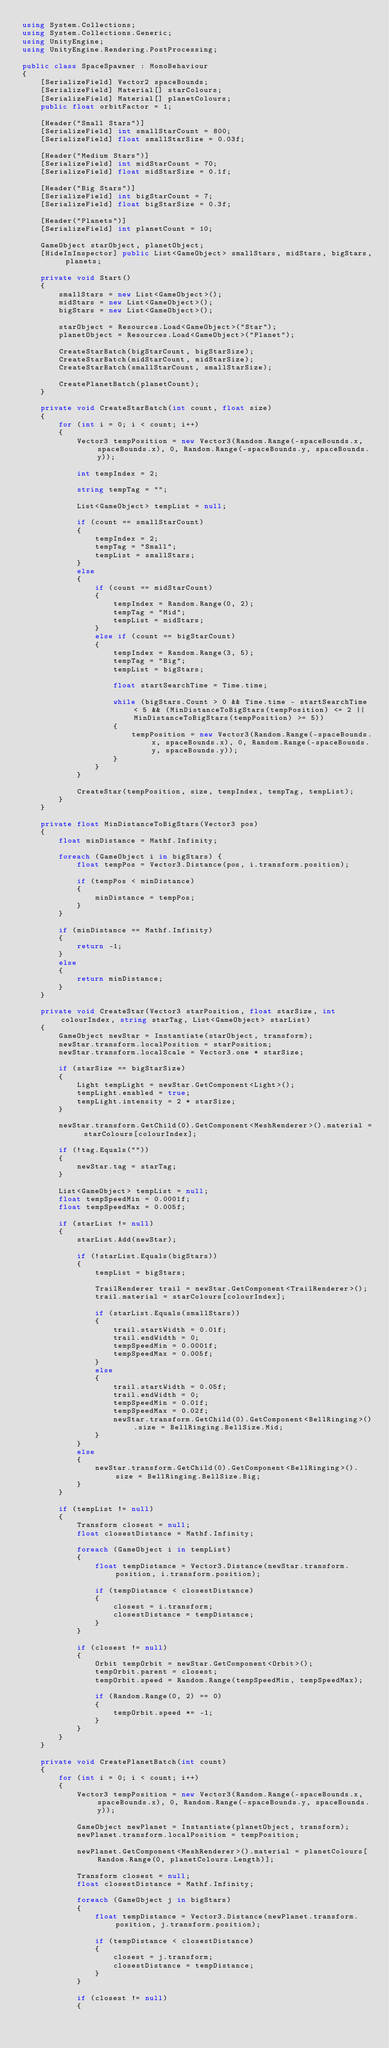Convert code to text. <code><loc_0><loc_0><loc_500><loc_500><_C#_>using System.Collections;
using System.Collections.Generic;
using UnityEngine;
using UnityEngine.Rendering.PostProcessing;

public class SpaceSpawner : MonoBehaviour
{
    [SerializeField] Vector2 spaceBounds;
    [SerializeField] Material[] starColours;
    [SerializeField] Material[] planetColours;
    public float orbitFactor = 1;

    [Header("Small Stars")]
    [SerializeField] int smallStarCount = 800;
    [SerializeField] float smallStarSize = 0.03f;

    [Header("Medium Stars")]
    [SerializeField] int midStarCount = 70;
    [SerializeField] float midStarSize = 0.1f;

    [Header("Big Stars")]
    [SerializeField] int bigStarCount = 7;
    [SerializeField] float bigStarSize = 0.3f;

    [Header("Planets")]
    [SerializeField] int planetCount = 10;

    GameObject starObject, planetObject;
    [HideInInspector] public List<GameObject> smallStars, midStars, bigStars, planets;

    private void Start()
    {
        smallStars = new List<GameObject>();
        midStars = new List<GameObject>();
        bigStars = new List<GameObject>();

        starObject = Resources.Load<GameObject>("Star");
        planetObject = Resources.Load<GameObject>("Planet");

        CreateStarBatch(bigStarCount, bigStarSize);
        CreateStarBatch(midStarCount, midStarSize);
        CreateStarBatch(smallStarCount, smallStarSize);

        CreatePlanetBatch(planetCount);
    }

    private void CreateStarBatch(int count, float size)
    {
        for (int i = 0; i < count; i++)
        {
            Vector3 tempPosition = new Vector3(Random.Range(-spaceBounds.x, spaceBounds.x), 0, Random.Range(-spaceBounds.y, spaceBounds.y));

            int tempIndex = 2;

            string tempTag = "";

            List<GameObject> tempList = null;

            if (count == smallStarCount)
            {
                tempIndex = 2;
                tempTag = "Small";
                tempList = smallStars;
            }
            else
            {
                if (count == midStarCount)
                {
                    tempIndex = Random.Range(0, 2);
                    tempTag = "Mid";
                    tempList = midStars;
                }
                else if (count == bigStarCount)
                {
                    tempIndex = Random.Range(3, 5);
                    tempTag = "Big";
                    tempList = bigStars;

                    float startSearchTime = Time.time;

                    while (bigStars.Count > 0 && Time.time - startSearchTime < 5 && (MinDistanceToBigStars(tempPosition) <= 2 || MinDistanceToBigStars(tempPosition) >= 5))
                    {
                        tempPosition = new Vector3(Random.Range(-spaceBounds.x, spaceBounds.x), 0, Random.Range(-spaceBounds.y, spaceBounds.y));
                    }
                }
            }

            CreateStar(tempPosition, size, tempIndex, tempTag, tempList);
        }
    }

    private float MinDistanceToBigStars(Vector3 pos)
    {
        float minDistance = Mathf.Infinity;

        foreach (GameObject i in bigStars) {
            float tempPos = Vector3.Distance(pos, i.transform.position);

            if (tempPos < minDistance)
            {
                minDistance = tempPos;
            }
        }

        if (minDistance == Mathf.Infinity)
        {
            return -1;
        }
        else
        {
            return minDistance;
        }
    }

    private void CreateStar(Vector3 starPosition, float starSize, int colourIndex, string starTag, List<GameObject> starList)
    {
        GameObject newStar = Instantiate(starObject, transform);
        newStar.transform.localPosition = starPosition;
        newStar.transform.localScale = Vector3.one * starSize;

        if (starSize == bigStarSize)
        {
            Light tempLight = newStar.GetComponent<Light>();
            tempLight.enabled = true;
            tempLight.intensity = 2 * starSize;
        }

        newStar.transform.GetChild(0).GetComponent<MeshRenderer>().material = starColours[colourIndex];

        if (!tag.Equals(""))
        {
            newStar.tag = starTag;
        }

        List<GameObject> tempList = null;
        float tempSpeedMin = 0.0001f;
        float tempSpeedMax = 0.005f;

        if (starList != null)
        {
            starList.Add(newStar);

            if (!starList.Equals(bigStars))
            {
                tempList = bigStars;

                TrailRenderer trail = newStar.GetComponent<TrailRenderer>();
                trail.material = starColours[colourIndex];

                if (starList.Equals(smallStars))
                {
                    trail.startWidth = 0.01f;
                    trail.endWidth = 0;
                    tempSpeedMin = 0.0001f;
                    tempSpeedMax = 0.005f;
                }
                else
                {
                    trail.startWidth = 0.05f;
                    trail.endWidth = 0;
                    tempSpeedMin = 0.01f;
                    tempSpeedMax = 0.02f;
                    newStar.transform.GetChild(0).GetComponent<BellRinging>().size = BellRinging.BellSize.Mid;
                }
            }
            else
            {
                newStar.transform.GetChild(0).GetComponent<BellRinging>().size = BellRinging.BellSize.Big;
            }
        }

        if (tempList != null)
        {
            Transform closest = null;
            float closestDistance = Mathf.Infinity;

            foreach (GameObject i in tempList)
            {
                float tempDistance = Vector3.Distance(newStar.transform.position, i.transform.position);

                if (tempDistance < closestDistance)
                {
                    closest = i.transform;
                    closestDistance = tempDistance;
                }
            }

            if (closest != null)
            {
                Orbit tempOrbit = newStar.GetComponent<Orbit>();
                tempOrbit.parent = closest;
                tempOrbit.speed = Random.Range(tempSpeedMin, tempSpeedMax);

                if (Random.Range(0, 2) == 0)
                {
                    tempOrbit.speed *= -1;
                }
            }
        }
    }

    private void CreatePlanetBatch(int count)
    {
        for (int i = 0; i < count; i++)
        {
            Vector3 tempPosition = new Vector3(Random.Range(-spaceBounds.x, spaceBounds.x), 0, Random.Range(-spaceBounds.y, spaceBounds.y));

            GameObject newPlanet = Instantiate(planetObject, transform);
            newPlanet.transform.localPosition = tempPosition;

            newPlanet.GetComponent<MeshRenderer>().material = planetColours[Random.Range(0, planetColours.Length)];

            Transform closest = null;
            float closestDistance = Mathf.Infinity;

            foreach (GameObject j in bigStars)
            {
                float tempDistance = Vector3.Distance(newPlanet.transform.position, j.transform.position);

                if (tempDistance < closestDistance)
                {
                    closest = j.transform;
                    closestDistance = tempDistance;
                }
            }

            if (closest != null)
            {</code> 